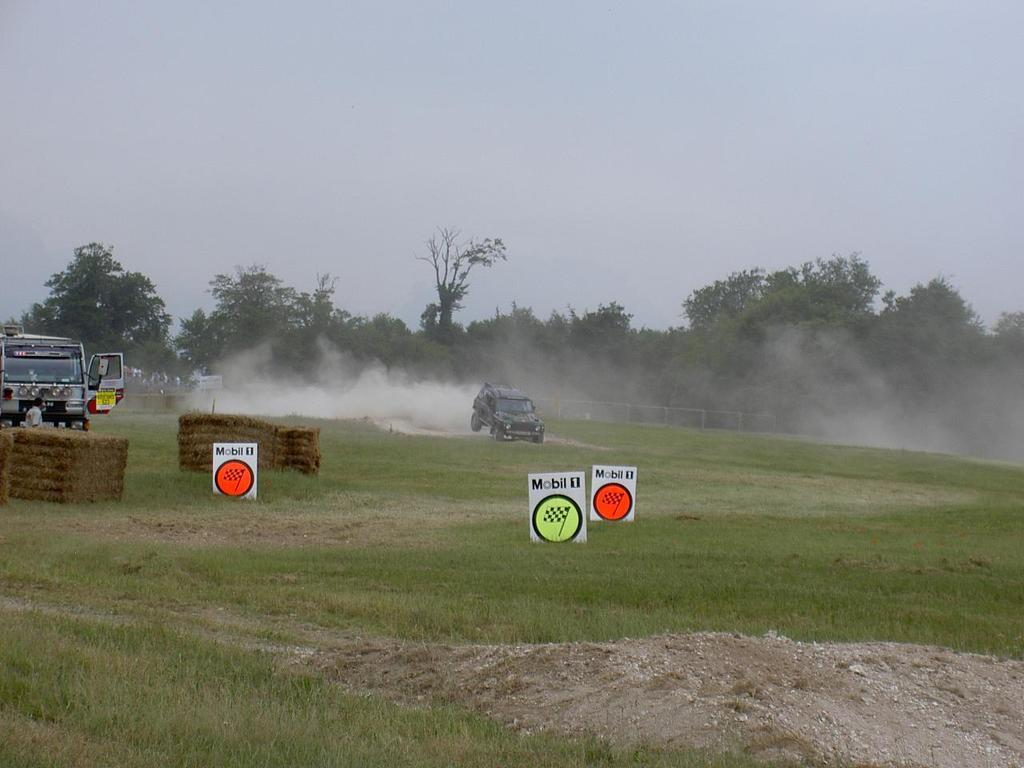What is the main subject of the image? There is a person in the image. What type of terrain is visible in the image? There is dried grass in the image. What else can be seen on the grass? There are vehicles on the grass. What objects are present in the image besides the person and vehicles? There are boards in the image. Can you describe the background of the image? There is smoke visible in the image, along with a fence, trees, and the sky. What type of boot is the person wearing in the image? There is no mention of a boot in the image. 